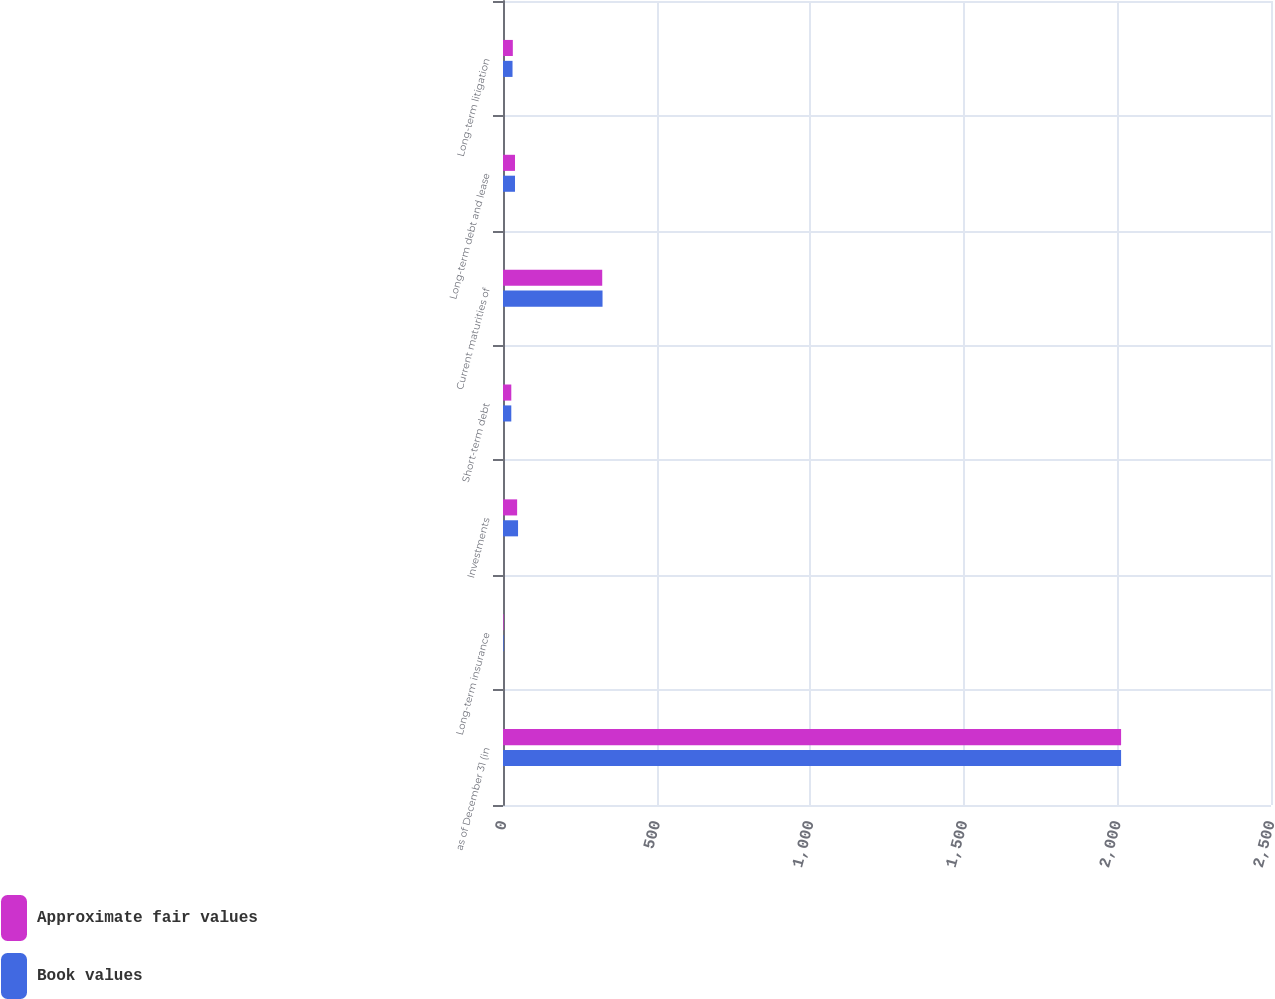Convert chart to OTSL. <chart><loc_0><loc_0><loc_500><loc_500><stacked_bar_chart><ecel><fcel>as of December 31 (in<fcel>Long-term insurance<fcel>Investments<fcel>Short-term debt<fcel>Current maturities of<fcel>Long-term debt and lease<fcel>Long-term litigation<nl><fcel>Approximate fair values<fcel>2012<fcel>2<fcel>46<fcel>27<fcel>323<fcel>39<fcel>32<nl><fcel>Book values<fcel>2012<fcel>2<fcel>49<fcel>27<fcel>324<fcel>39<fcel>31<nl></chart> 